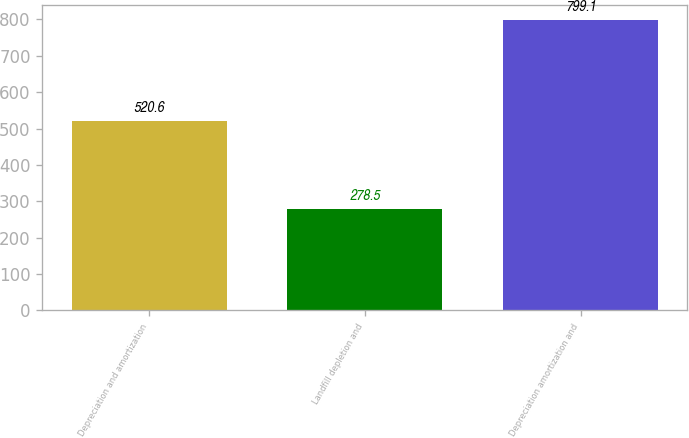Convert chart. <chart><loc_0><loc_0><loc_500><loc_500><bar_chart><fcel>Depreciation and amortization<fcel>Landfill depletion and<fcel>Depreciation amortization and<nl><fcel>520.6<fcel>278.5<fcel>799.1<nl></chart> 